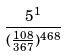Convert formula to latex. <formula><loc_0><loc_0><loc_500><loc_500>\frac { 5 ^ { 1 } } { ( \frac { 1 0 8 } { 3 6 7 } ) ^ { 4 6 8 } }</formula> 